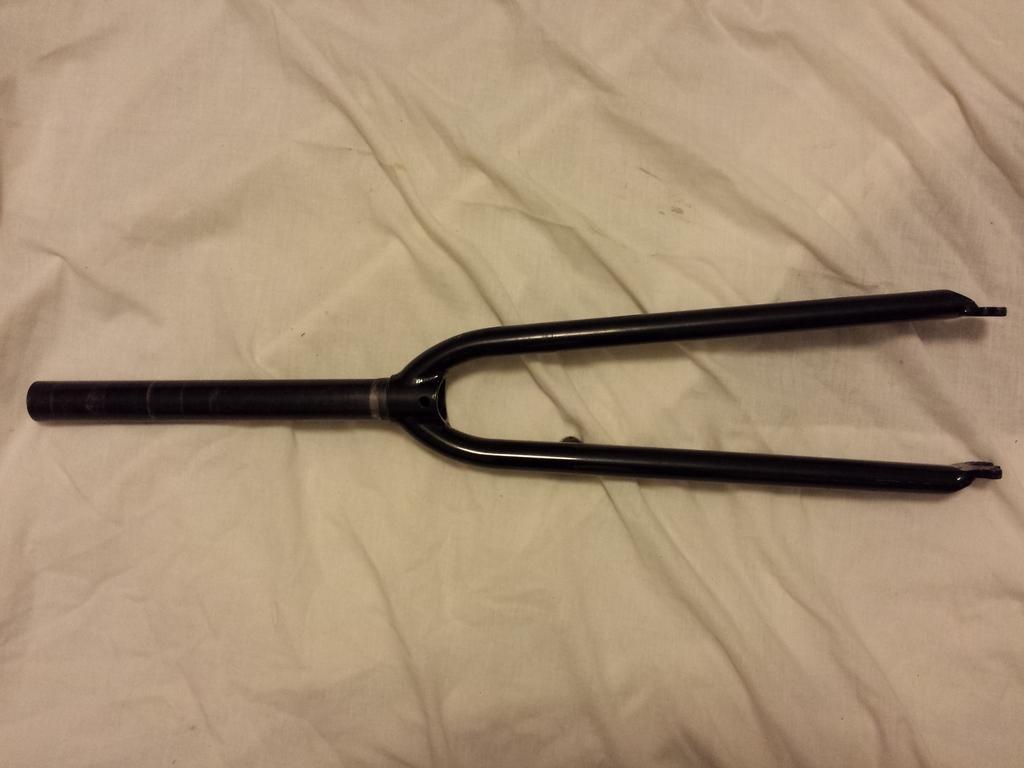Could you give a brief overview of what you see in this image? In this picture there is an object. At the bottom there is a white cloth. 